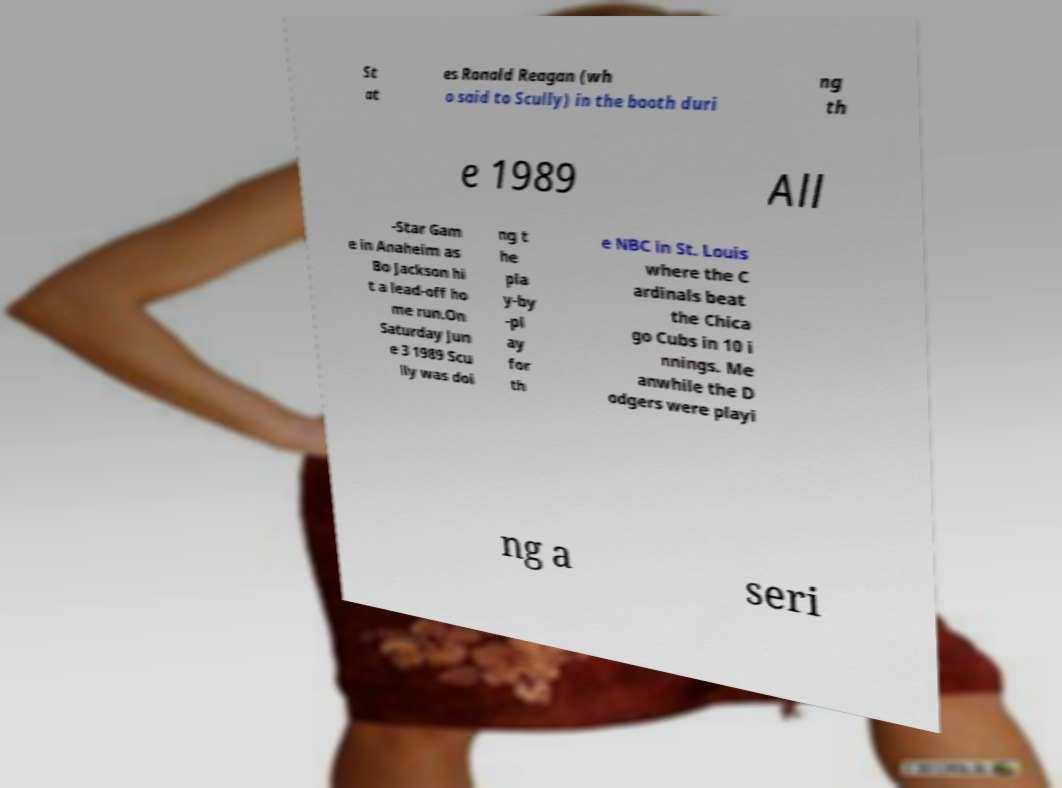Can you read and provide the text displayed in the image?This photo seems to have some interesting text. Can you extract and type it out for me? St at es Ronald Reagan (wh o said to Scully) in the booth duri ng th e 1989 All -Star Gam e in Anaheim as Bo Jackson hi t a lead-off ho me run.On Saturday Jun e 3 1989 Scu lly was doi ng t he pla y-by -pl ay for th e NBC in St. Louis where the C ardinals beat the Chica go Cubs in 10 i nnings. Me anwhile the D odgers were playi ng a seri 